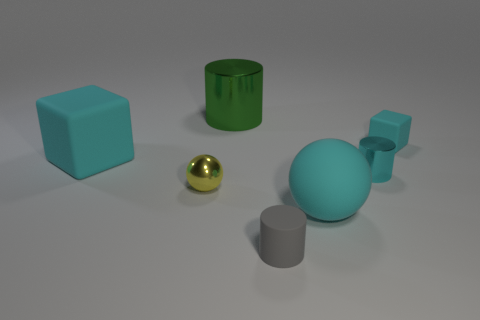Subtract all cyan shiny cylinders. How many cylinders are left? 2 Add 2 large blue matte objects. How many objects exist? 9 Subtract all gray cylinders. How many cylinders are left? 2 Subtract 2 cylinders. How many cylinders are left? 1 Subtract all cylinders. How many objects are left? 4 Add 5 large purple metallic objects. How many large purple metallic objects exist? 5 Subtract 0 blue blocks. How many objects are left? 7 Subtract all blue cubes. Subtract all cyan balls. How many cubes are left? 2 Subtract all cyan shiny things. Subtract all tiny cyan cylinders. How many objects are left? 5 Add 3 cyan objects. How many cyan objects are left? 7 